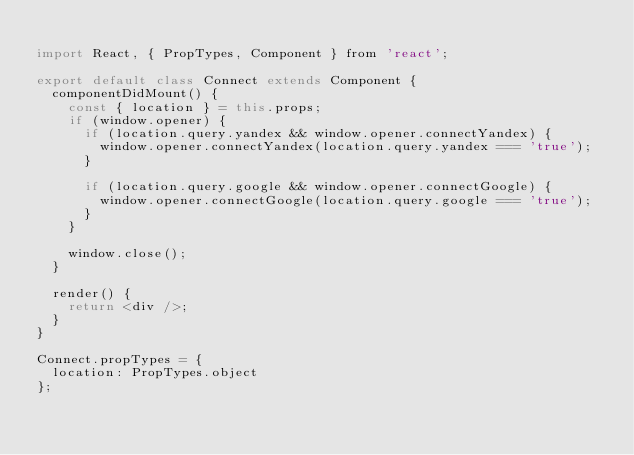<code> <loc_0><loc_0><loc_500><loc_500><_JavaScript_>
import React, { PropTypes, Component } from 'react';

export default class Connect extends Component {
  componentDidMount() {
    const { location } = this.props;
    if (window.opener) {
      if (location.query.yandex && window.opener.connectYandex) {
        window.opener.connectYandex(location.query.yandex === 'true');
      }

      if (location.query.google && window.opener.connectGoogle) {
        window.opener.connectGoogle(location.query.google === 'true');
      }
    }

    window.close();
  }

  render() {
    return <div />;
  }
}

Connect.propTypes = {
  location: PropTypes.object
};
</code> 